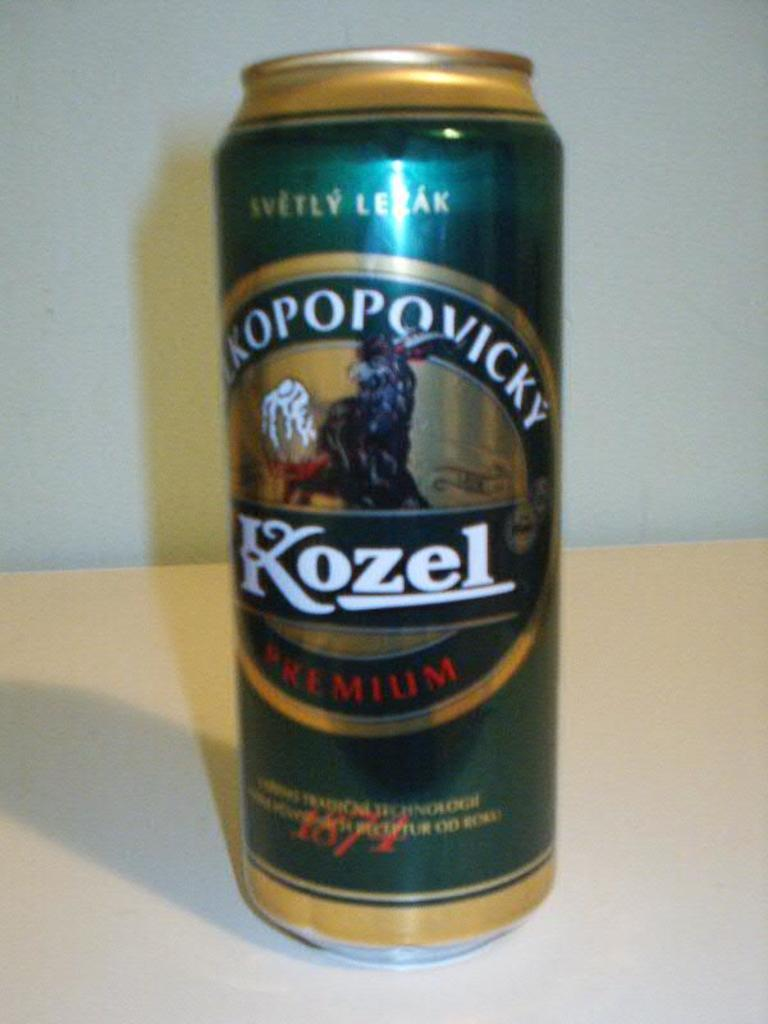<image>
Create a compact narrative representing the image presented. green and golden yellow can with kopovicky name and KOZEL brand on it 